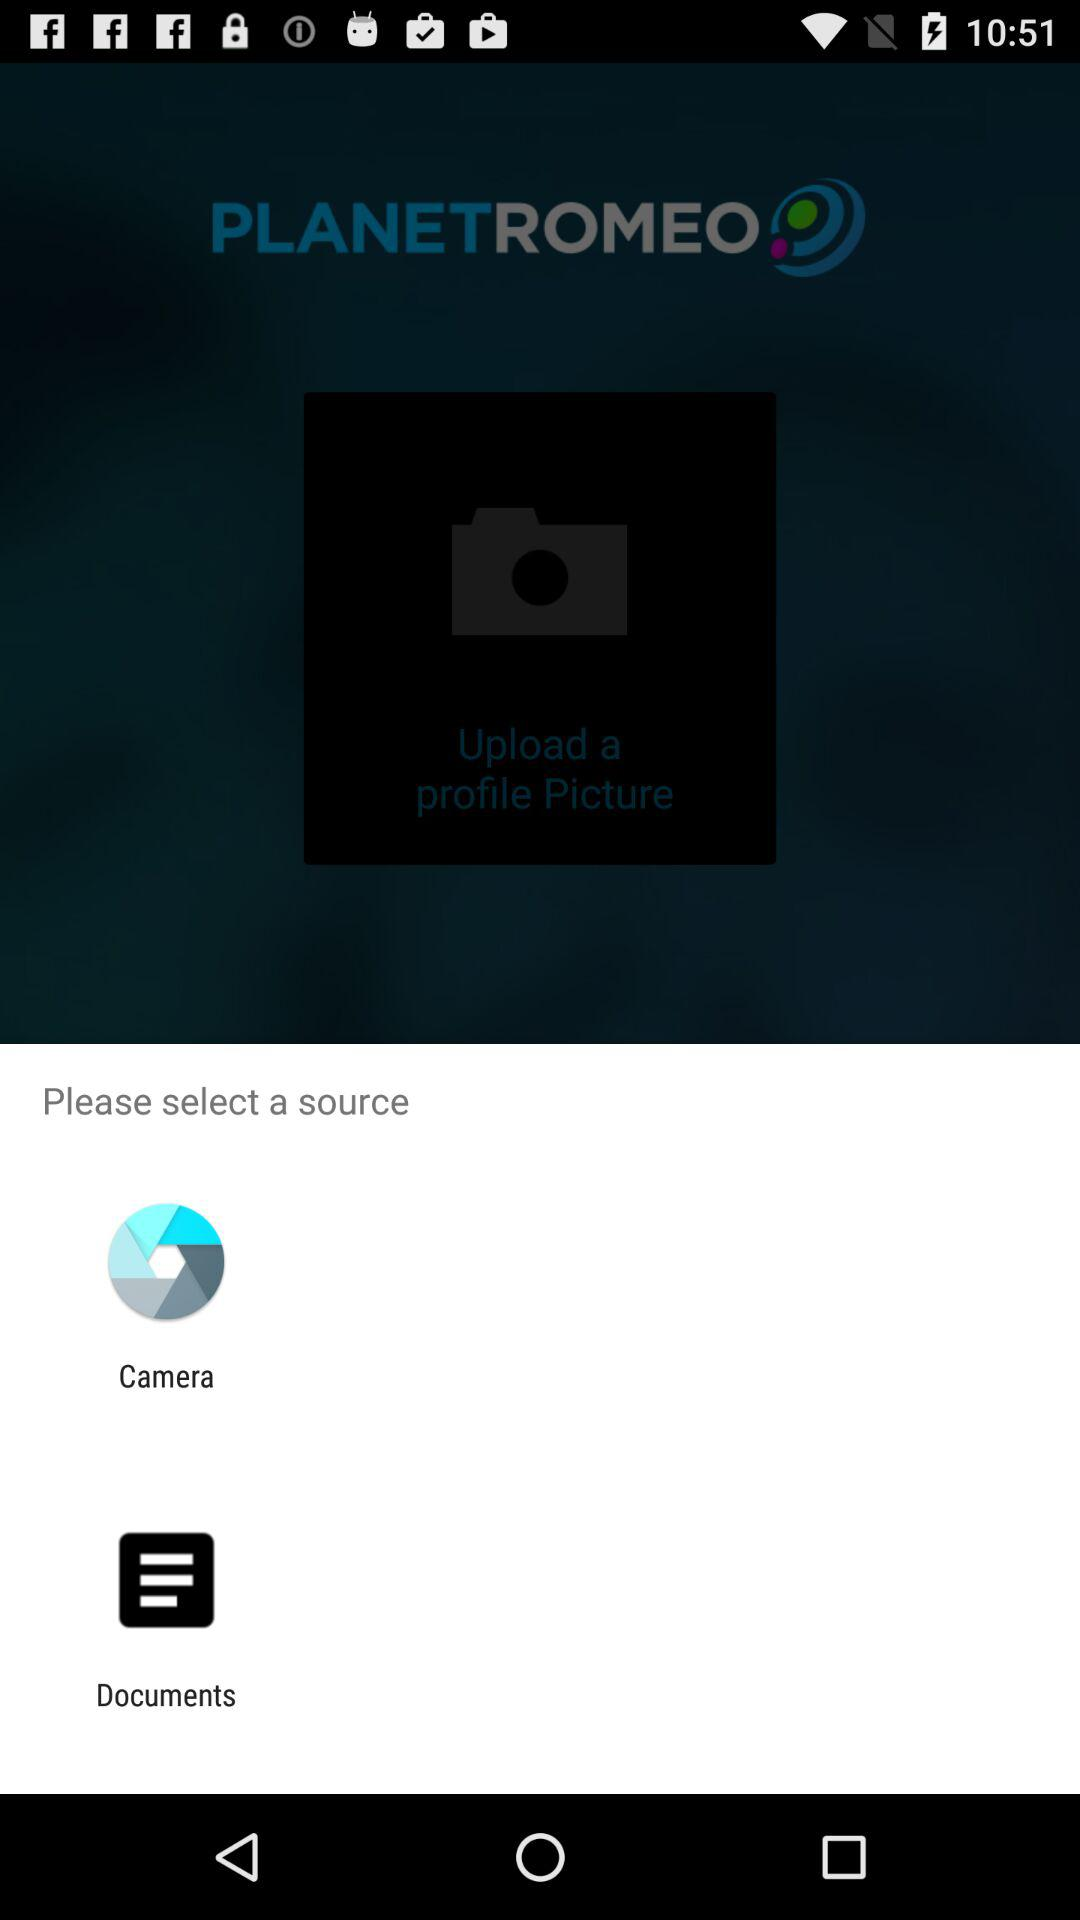How many images will be uploaded?
When the provided information is insufficient, respond with <no answer>. <no answer> 